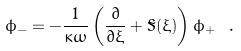<formula> <loc_0><loc_0><loc_500><loc_500>\phi _ { - } = - \frac { 1 } { \kappa \omega } \left ( \frac { \partial } { \partial \xi } + \tilde { S } ( \xi ) \right ) \phi _ { + } \ .</formula> 